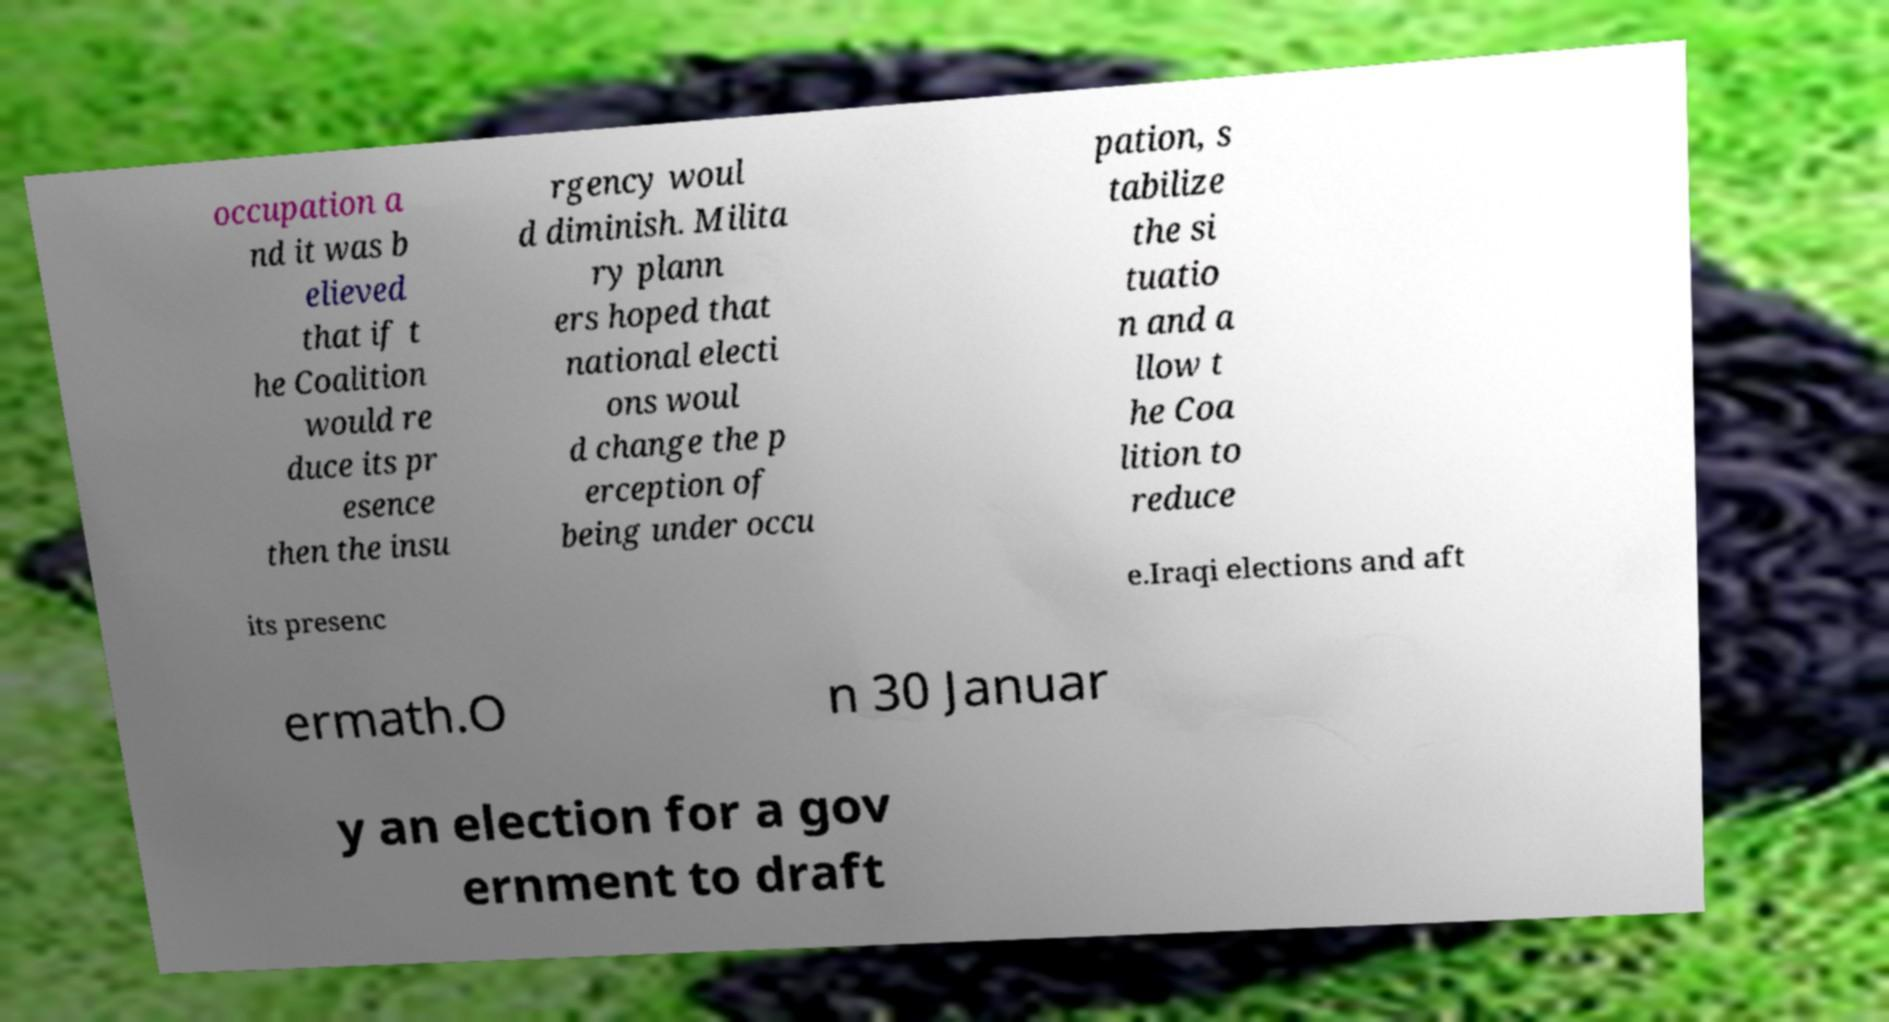Can you accurately transcribe the text from the provided image for me? occupation a nd it was b elieved that if t he Coalition would re duce its pr esence then the insu rgency woul d diminish. Milita ry plann ers hoped that national electi ons woul d change the p erception of being under occu pation, s tabilize the si tuatio n and a llow t he Coa lition to reduce its presenc e.Iraqi elections and aft ermath.O n 30 Januar y an election for a gov ernment to draft 